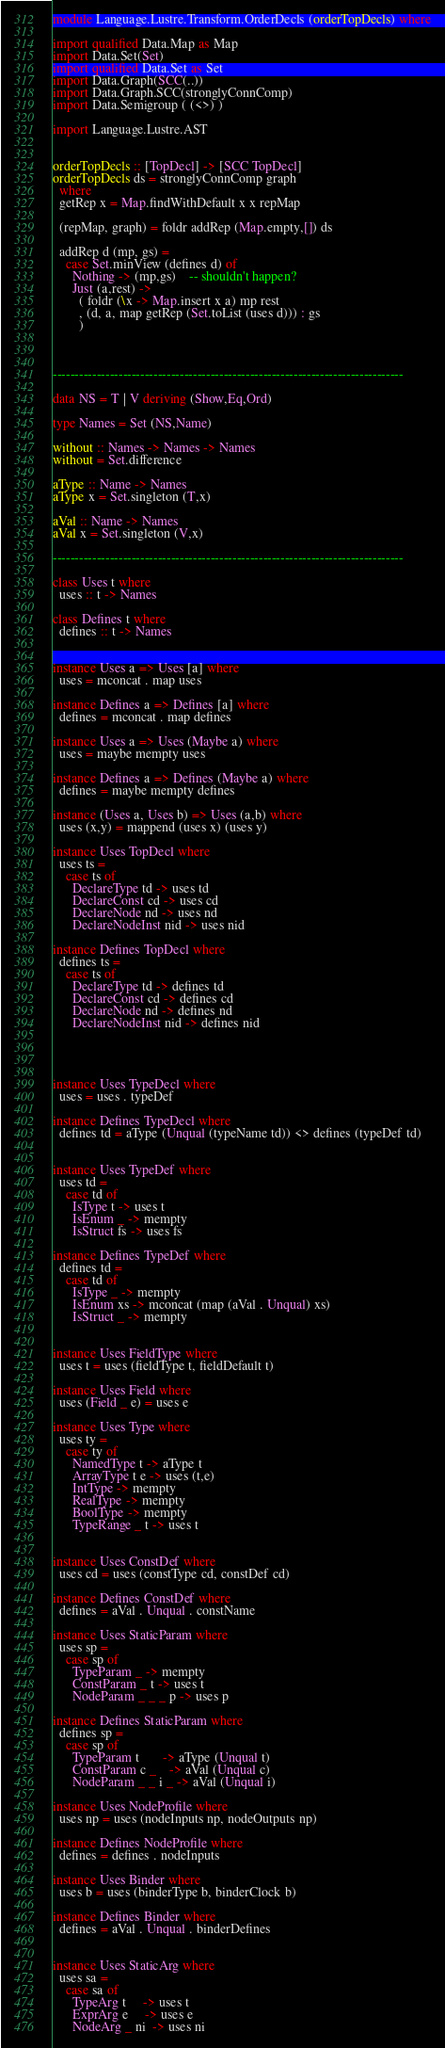Convert code to text. <code><loc_0><loc_0><loc_500><loc_500><_Haskell_>module Language.Lustre.Transform.OrderDecls (orderTopDecls) where

import qualified Data.Map as Map
import Data.Set(Set)
import qualified Data.Set as Set
import Data.Graph(SCC(..))
import Data.Graph.SCC(stronglyConnComp)
import Data.Semigroup ( (<>) )

import Language.Lustre.AST


orderTopDecls :: [TopDecl] -> [SCC TopDecl]
orderTopDecls ds = stronglyConnComp graph
  where
  getRep x = Map.findWithDefault x x repMap

  (repMap, graph) = foldr addRep (Map.empty,[]) ds

  addRep d (mp, gs) =
    case Set.minView (defines d) of
      Nothing -> (mp,gs)    -- shouldn't happen?
      Just (a,rest) ->
        ( foldr (\x -> Map.insert x a) mp rest
        , (d, a, map getRep (Set.toList (uses d))) : gs
        )



--------------------------------------------------------------------------------

data NS = T | V deriving (Show,Eq,Ord)

type Names = Set (NS,Name)

without :: Names -> Names -> Names
without = Set.difference

aType :: Name -> Names
aType x = Set.singleton (T,x)

aVal :: Name -> Names
aVal x = Set.singleton (V,x)

--------------------------------------------------------------------------------

class Uses t where
  uses :: t -> Names

class Defines t where
  defines :: t -> Names


instance Uses a => Uses [a] where
  uses = mconcat . map uses

instance Defines a => Defines [a] where
  defines = mconcat . map defines

instance Uses a => Uses (Maybe a) where
  uses = maybe mempty uses

instance Defines a => Defines (Maybe a) where
  defines = maybe mempty defines

instance (Uses a, Uses b) => Uses (a,b) where
  uses (x,y) = mappend (uses x) (uses y)

instance Uses TopDecl where
  uses ts =
    case ts of
      DeclareType td -> uses td
      DeclareConst cd -> uses cd
      DeclareNode nd -> uses nd
      DeclareNodeInst nid -> uses nid

instance Defines TopDecl where
  defines ts =
    case ts of
      DeclareType td -> defines td
      DeclareConst cd -> defines cd
      DeclareNode nd -> defines nd
      DeclareNodeInst nid -> defines nid




instance Uses TypeDecl where
  uses = uses . typeDef

instance Defines TypeDecl where
  defines td = aType (Unqual (typeName td)) <> defines (typeDef td)


instance Uses TypeDef where
  uses td =
    case td of
      IsType t -> uses t
      IsEnum _ -> mempty
      IsStruct fs -> uses fs

instance Defines TypeDef where
  defines td =
    case td of
      IsType _ -> mempty
      IsEnum xs -> mconcat (map (aVal . Unqual) xs)
      IsStruct _ -> mempty


instance Uses FieldType where
  uses t = uses (fieldType t, fieldDefault t)

instance Uses Field where
  uses (Field _ e) = uses e

instance Uses Type where
  uses ty =
    case ty of
      NamedType t -> aType t
      ArrayType t e -> uses (t,e)
      IntType -> mempty
      RealType -> mempty
      BoolType -> mempty
      TypeRange _ t -> uses t


instance Uses ConstDef where
  uses cd = uses (constType cd, constDef cd)

instance Defines ConstDef where
  defines = aVal . Unqual . constName

instance Uses StaticParam where
  uses sp =
    case sp of
      TypeParam _ -> mempty
      ConstParam _ t -> uses t
      NodeParam _ _ _ p -> uses p

instance Defines StaticParam where
  defines sp =
    case sp of
      TypeParam t       -> aType (Unqual t)
      ConstParam c _    -> aVal (Unqual c)
      NodeParam _ _ i _ -> aVal (Unqual i)

instance Uses NodeProfile where
  uses np = uses (nodeInputs np, nodeOutputs np)

instance Defines NodeProfile where
  defines = defines . nodeInputs

instance Uses Binder where
  uses b = uses (binderType b, binderClock b)

instance Defines Binder where
  defines = aVal . Unqual . binderDefines


instance Uses StaticArg where
  uses sa =
    case sa of
      TypeArg t     -> uses t
      ExprArg e     -> uses e
      NodeArg _ ni  -> uses ni</code> 